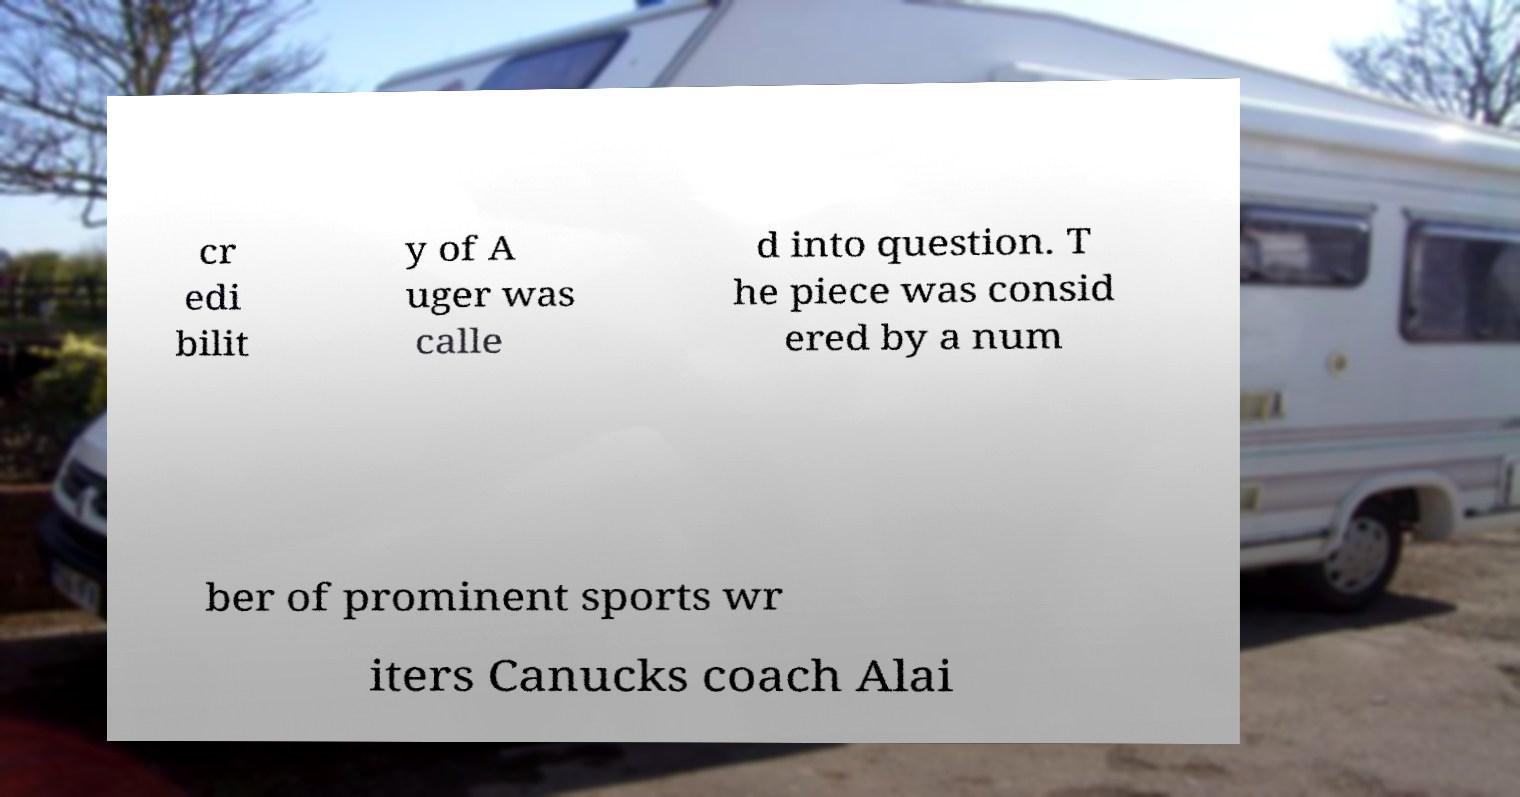Could you assist in decoding the text presented in this image and type it out clearly? cr edi bilit y of A uger was calle d into question. T he piece was consid ered by a num ber of prominent sports wr iters Canucks coach Alai 